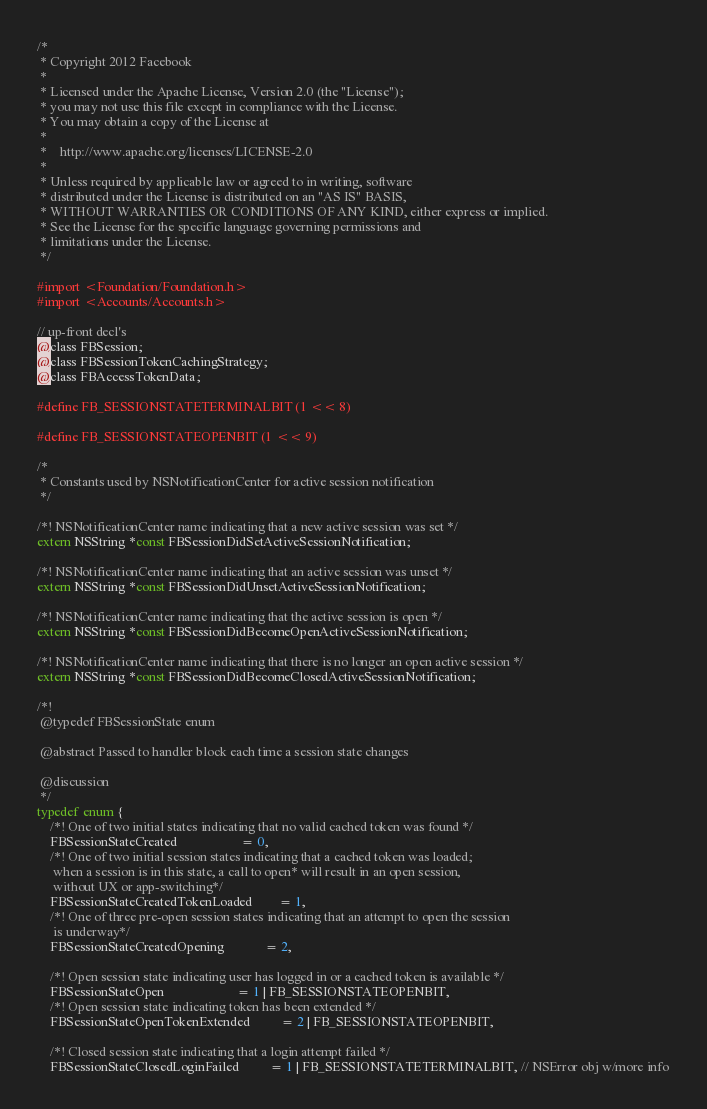Convert code to text. <code><loc_0><loc_0><loc_500><loc_500><_C_>/*
 * Copyright 2012 Facebook
 *
 * Licensed under the Apache License, Version 2.0 (the "License");
 * you may not use this file except in compliance with the License.
 * You may obtain a copy of the License at
 *
 *    http://www.apache.org/licenses/LICENSE-2.0
 *
 * Unless required by applicable law or agreed to in writing, software
 * distributed under the License is distributed on an "AS IS" BASIS,
 * WITHOUT WARRANTIES OR CONDITIONS OF ANY KIND, either express or implied.
 * See the License for the specific language governing permissions and
 * limitations under the License.
 */

#import <Foundation/Foundation.h>
#import <Accounts/Accounts.h>

// up-front decl's
@class FBSession;
@class FBSessionTokenCachingStrategy;
@class FBAccessTokenData;

#define FB_SESSIONSTATETERMINALBIT (1 << 8)

#define FB_SESSIONSTATEOPENBIT (1 << 9)

/*
 * Constants used by NSNotificationCenter for active session notification
 */

/*! NSNotificationCenter name indicating that a new active session was set */
extern NSString *const FBSessionDidSetActiveSessionNotification;

/*! NSNotificationCenter name indicating that an active session was unset */
extern NSString *const FBSessionDidUnsetActiveSessionNotification;

/*! NSNotificationCenter name indicating that the active session is open */
extern NSString *const FBSessionDidBecomeOpenActiveSessionNotification;

/*! NSNotificationCenter name indicating that there is no longer an open active session */
extern NSString *const FBSessionDidBecomeClosedActiveSessionNotification;

/*! 
 @typedef FBSessionState enum
 
 @abstract Passed to handler block each time a session state changes
 
 @discussion
 */
typedef enum {
    /*! One of two initial states indicating that no valid cached token was found */
    FBSessionStateCreated                   = 0,
    /*! One of two initial session states indicating that a cached token was loaded;
     when a session is in this state, a call to open* will result in an open session,
     without UX or app-switching*/
    FBSessionStateCreatedTokenLoaded        = 1,
    /*! One of three pre-open session states indicating that an attempt to open the session
     is underway*/
    FBSessionStateCreatedOpening            = 2,
    
    /*! Open session state indicating user has logged in or a cached token is available */
    FBSessionStateOpen                      = 1 | FB_SESSIONSTATEOPENBIT,
    /*! Open session state indicating token has been extended */
    FBSessionStateOpenTokenExtended         = 2 | FB_SESSIONSTATEOPENBIT,
    
    /*! Closed session state indicating that a login attempt failed */
    FBSessionStateClosedLoginFailed         = 1 | FB_SESSIONSTATETERMINALBIT, // NSError obj w/more info</code> 